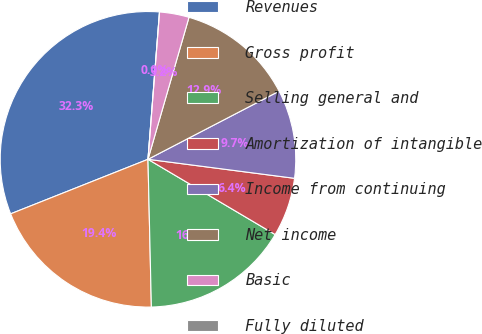Convert chart to OTSL. <chart><loc_0><loc_0><loc_500><loc_500><pie_chart><fcel>Revenues<fcel>Gross profit<fcel>Selling general and<fcel>Amortization of intangible<fcel>Income from continuing<fcel>Net income<fcel>Basic<fcel>Fully diluted<nl><fcel>32.26%<fcel>19.35%<fcel>16.13%<fcel>6.45%<fcel>9.68%<fcel>12.9%<fcel>3.23%<fcel>0.0%<nl></chart> 